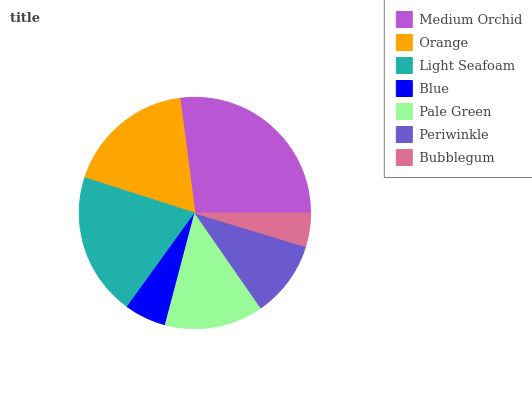Is Bubblegum the minimum?
Answer yes or no. Yes. Is Medium Orchid the maximum?
Answer yes or no. Yes. Is Orange the minimum?
Answer yes or no. No. Is Orange the maximum?
Answer yes or no. No. Is Medium Orchid greater than Orange?
Answer yes or no. Yes. Is Orange less than Medium Orchid?
Answer yes or no. Yes. Is Orange greater than Medium Orchid?
Answer yes or no. No. Is Medium Orchid less than Orange?
Answer yes or no. No. Is Pale Green the high median?
Answer yes or no. Yes. Is Pale Green the low median?
Answer yes or no. Yes. Is Orange the high median?
Answer yes or no. No. Is Orange the low median?
Answer yes or no. No. 